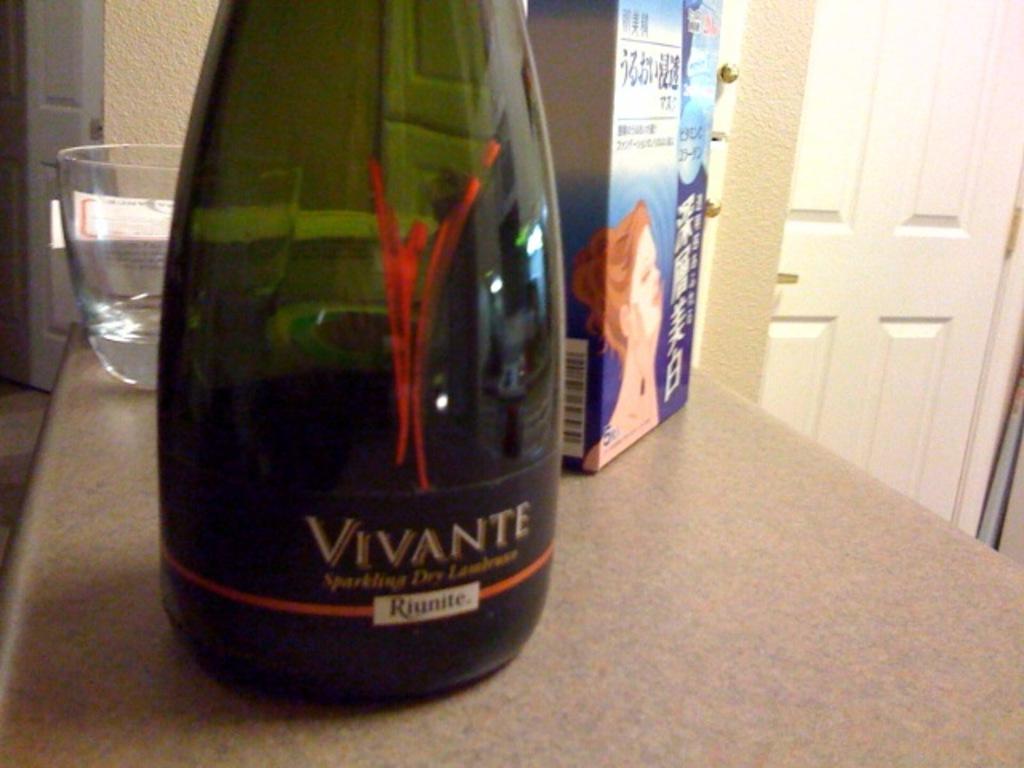In one or two sentences, can you explain what this image depicts? There is a bottle on the table. There is glass next to it other side one cover packet is there. We can see on the background there is a doors and walls. 